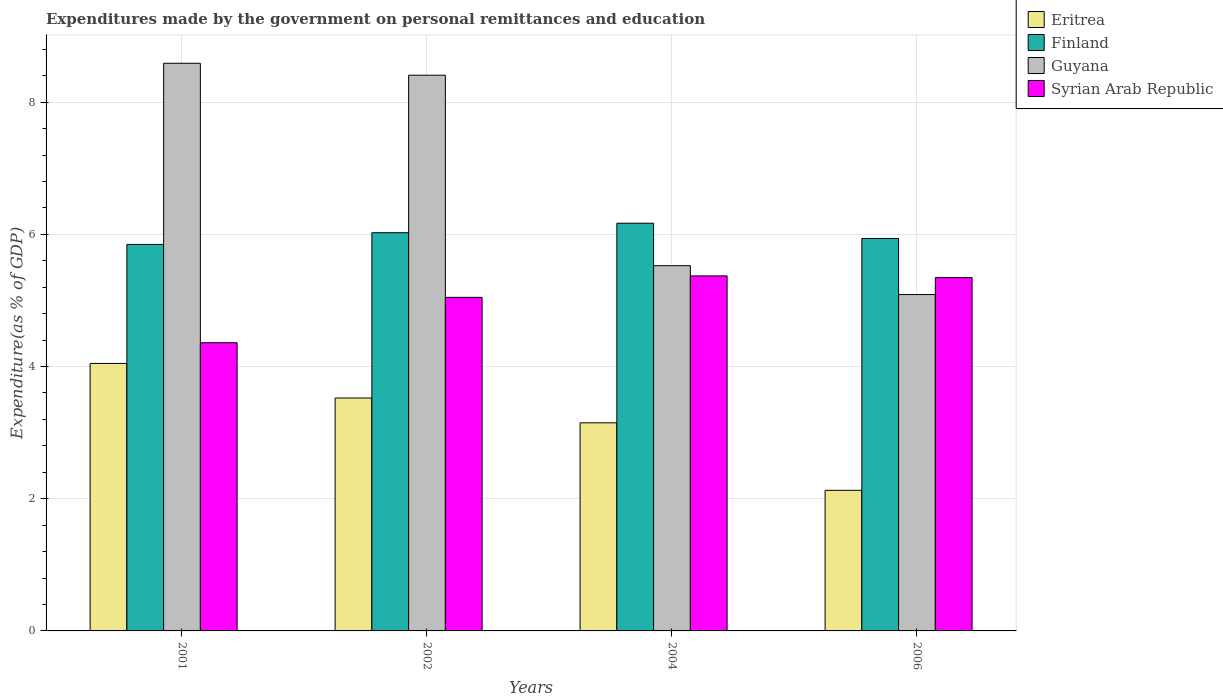How many different coloured bars are there?
Offer a very short reply. 4. Are the number of bars per tick equal to the number of legend labels?
Offer a terse response. Yes. Are the number of bars on each tick of the X-axis equal?
Make the answer very short. Yes. How many bars are there on the 2nd tick from the right?
Ensure brevity in your answer.  4. What is the label of the 2nd group of bars from the left?
Offer a terse response. 2002. What is the expenditures made by the government on personal remittances and education in Syrian Arab Republic in 2002?
Keep it short and to the point. 5.05. Across all years, what is the maximum expenditures made by the government on personal remittances and education in Syrian Arab Republic?
Provide a succinct answer. 5.37. Across all years, what is the minimum expenditures made by the government on personal remittances and education in Guyana?
Offer a terse response. 5.09. In which year was the expenditures made by the government on personal remittances and education in Eritrea minimum?
Provide a succinct answer. 2006. What is the total expenditures made by the government on personal remittances and education in Finland in the graph?
Give a very brief answer. 23.98. What is the difference between the expenditures made by the government on personal remittances and education in Eritrea in 2002 and that in 2004?
Give a very brief answer. 0.37. What is the difference between the expenditures made by the government on personal remittances and education in Finland in 2002 and the expenditures made by the government on personal remittances and education in Eritrea in 2004?
Offer a terse response. 2.88. What is the average expenditures made by the government on personal remittances and education in Syrian Arab Republic per year?
Provide a succinct answer. 5.03. In the year 2006, what is the difference between the expenditures made by the government on personal remittances and education in Finland and expenditures made by the government on personal remittances and education in Syrian Arab Republic?
Make the answer very short. 0.59. In how many years, is the expenditures made by the government on personal remittances and education in Finland greater than 8.4 %?
Keep it short and to the point. 0. What is the ratio of the expenditures made by the government on personal remittances and education in Finland in 2004 to that in 2006?
Your answer should be compact. 1.04. Is the difference between the expenditures made by the government on personal remittances and education in Finland in 2001 and 2006 greater than the difference between the expenditures made by the government on personal remittances and education in Syrian Arab Republic in 2001 and 2006?
Your answer should be compact. Yes. What is the difference between the highest and the second highest expenditures made by the government on personal remittances and education in Eritrea?
Provide a short and direct response. 0.52. What is the difference between the highest and the lowest expenditures made by the government on personal remittances and education in Eritrea?
Ensure brevity in your answer.  1.92. Is the sum of the expenditures made by the government on personal remittances and education in Finland in 2002 and 2004 greater than the maximum expenditures made by the government on personal remittances and education in Syrian Arab Republic across all years?
Give a very brief answer. Yes. What does the 4th bar from the left in 2001 represents?
Offer a terse response. Syrian Arab Republic. What does the 2nd bar from the right in 2001 represents?
Offer a very short reply. Guyana. Is it the case that in every year, the sum of the expenditures made by the government on personal remittances and education in Finland and expenditures made by the government on personal remittances and education in Eritrea is greater than the expenditures made by the government on personal remittances and education in Syrian Arab Republic?
Your response must be concise. Yes. How many bars are there?
Your response must be concise. 16. Are all the bars in the graph horizontal?
Ensure brevity in your answer.  No. How many years are there in the graph?
Your answer should be very brief. 4. What is the difference between two consecutive major ticks on the Y-axis?
Give a very brief answer. 2. Does the graph contain any zero values?
Ensure brevity in your answer.  No. Does the graph contain grids?
Ensure brevity in your answer.  Yes. What is the title of the graph?
Your response must be concise. Expenditures made by the government on personal remittances and education. What is the label or title of the X-axis?
Offer a very short reply. Years. What is the label or title of the Y-axis?
Make the answer very short. Expenditure(as % of GDP). What is the Expenditure(as % of GDP) in Eritrea in 2001?
Your answer should be very brief. 4.05. What is the Expenditure(as % of GDP) in Finland in 2001?
Make the answer very short. 5.85. What is the Expenditure(as % of GDP) in Guyana in 2001?
Ensure brevity in your answer.  8.59. What is the Expenditure(as % of GDP) of Syrian Arab Republic in 2001?
Provide a short and direct response. 4.36. What is the Expenditure(as % of GDP) of Eritrea in 2002?
Give a very brief answer. 3.52. What is the Expenditure(as % of GDP) in Finland in 2002?
Give a very brief answer. 6.02. What is the Expenditure(as % of GDP) in Guyana in 2002?
Give a very brief answer. 8.41. What is the Expenditure(as % of GDP) in Syrian Arab Republic in 2002?
Provide a short and direct response. 5.05. What is the Expenditure(as % of GDP) of Eritrea in 2004?
Keep it short and to the point. 3.15. What is the Expenditure(as % of GDP) in Finland in 2004?
Make the answer very short. 6.17. What is the Expenditure(as % of GDP) in Guyana in 2004?
Provide a succinct answer. 5.53. What is the Expenditure(as % of GDP) in Syrian Arab Republic in 2004?
Provide a succinct answer. 5.37. What is the Expenditure(as % of GDP) of Eritrea in 2006?
Provide a short and direct response. 2.13. What is the Expenditure(as % of GDP) of Finland in 2006?
Provide a succinct answer. 5.94. What is the Expenditure(as % of GDP) of Guyana in 2006?
Give a very brief answer. 5.09. What is the Expenditure(as % of GDP) of Syrian Arab Republic in 2006?
Your response must be concise. 5.35. Across all years, what is the maximum Expenditure(as % of GDP) in Eritrea?
Your answer should be very brief. 4.05. Across all years, what is the maximum Expenditure(as % of GDP) in Finland?
Offer a terse response. 6.17. Across all years, what is the maximum Expenditure(as % of GDP) in Guyana?
Keep it short and to the point. 8.59. Across all years, what is the maximum Expenditure(as % of GDP) in Syrian Arab Republic?
Keep it short and to the point. 5.37. Across all years, what is the minimum Expenditure(as % of GDP) in Eritrea?
Provide a short and direct response. 2.13. Across all years, what is the minimum Expenditure(as % of GDP) of Finland?
Offer a terse response. 5.85. Across all years, what is the minimum Expenditure(as % of GDP) in Guyana?
Keep it short and to the point. 5.09. Across all years, what is the minimum Expenditure(as % of GDP) in Syrian Arab Republic?
Offer a terse response. 4.36. What is the total Expenditure(as % of GDP) in Eritrea in the graph?
Provide a succinct answer. 12.85. What is the total Expenditure(as % of GDP) in Finland in the graph?
Ensure brevity in your answer.  23.98. What is the total Expenditure(as % of GDP) of Guyana in the graph?
Give a very brief answer. 27.61. What is the total Expenditure(as % of GDP) of Syrian Arab Republic in the graph?
Offer a terse response. 20.12. What is the difference between the Expenditure(as % of GDP) in Eritrea in 2001 and that in 2002?
Offer a very short reply. 0.52. What is the difference between the Expenditure(as % of GDP) in Finland in 2001 and that in 2002?
Provide a short and direct response. -0.18. What is the difference between the Expenditure(as % of GDP) in Guyana in 2001 and that in 2002?
Keep it short and to the point. 0.18. What is the difference between the Expenditure(as % of GDP) of Syrian Arab Republic in 2001 and that in 2002?
Keep it short and to the point. -0.69. What is the difference between the Expenditure(as % of GDP) of Eritrea in 2001 and that in 2004?
Offer a very short reply. 0.9. What is the difference between the Expenditure(as % of GDP) of Finland in 2001 and that in 2004?
Provide a succinct answer. -0.32. What is the difference between the Expenditure(as % of GDP) in Guyana in 2001 and that in 2004?
Make the answer very short. 3.06. What is the difference between the Expenditure(as % of GDP) of Syrian Arab Republic in 2001 and that in 2004?
Offer a terse response. -1.01. What is the difference between the Expenditure(as % of GDP) of Eritrea in 2001 and that in 2006?
Provide a succinct answer. 1.92. What is the difference between the Expenditure(as % of GDP) of Finland in 2001 and that in 2006?
Your answer should be very brief. -0.09. What is the difference between the Expenditure(as % of GDP) of Guyana in 2001 and that in 2006?
Give a very brief answer. 3.5. What is the difference between the Expenditure(as % of GDP) in Syrian Arab Republic in 2001 and that in 2006?
Give a very brief answer. -0.99. What is the difference between the Expenditure(as % of GDP) in Eritrea in 2002 and that in 2004?
Ensure brevity in your answer.  0.37. What is the difference between the Expenditure(as % of GDP) of Finland in 2002 and that in 2004?
Make the answer very short. -0.14. What is the difference between the Expenditure(as % of GDP) of Guyana in 2002 and that in 2004?
Your response must be concise. 2.88. What is the difference between the Expenditure(as % of GDP) in Syrian Arab Republic in 2002 and that in 2004?
Give a very brief answer. -0.32. What is the difference between the Expenditure(as % of GDP) in Eritrea in 2002 and that in 2006?
Your answer should be compact. 1.4. What is the difference between the Expenditure(as % of GDP) in Finland in 2002 and that in 2006?
Make the answer very short. 0.09. What is the difference between the Expenditure(as % of GDP) of Guyana in 2002 and that in 2006?
Give a very brief answer. 3.32. What is the difference between the Expenditure(as % of GDP) in Syrian Arab Republic in 2002 and that in 2006?
Provide a succinct answer. -0.3. What is the difference between the Expenditure(as % of GDP) of Eritrea in 2004 and that in 2006?
Keep it short and to the point. 1.02. What is the difference between the Expenditure(as % of GDP) in Finland in 2004 and that in 2006?
Provide a short and direct response. 0.23. What is the difference between the Expenditure(as % of GDP) of Guyana in 2004 and that in 2006?
Give a very brief answer. 0.44. What is the difference between the Expenditure(as % of GDP) in Syrian Arab Republic in 2004 and that in 2006?
Provide a succinct answer. 0.03. What is the difference between the Expenditure(as % of GDP) in Eritrea in 2001 and the Expenditure(as % of GDP) in Finland in 2002?
Your answer should be compact. -1.98. What is the difference between the Expenditure(as % of GDP) in Eritrea in 2001 and the Expenditure(as % of GDP) in Guyana in 2002?
Offer a terse response. -4.36. What is the difference between the Expenditure(as % of GDP) of Eritrea in 2001 and the Expenditure(as % of GDP) of Syrian Arab Republic in 2002?
Provide a short and direct response. -1. What is the difference between the Expenditure(as % of GDP) of Finland in 2001 and the Expenditure(as % of GDP) of Guyana in 2002?
Your response must be concise. -2.56. What is the difference between the Expenditure(as % of GDP) in Finland in 2001 and the Expenditure(as % of GDP) in Syrian Arab Republic in 2002?
Your response must be concise. 0.8. What is the difference between the Expenditure(as % of GDP) of Guyana in 2001 and the Expenditure(as % of GDP) of Syrian Arab Republic in 2002?
Ensure brevity in your answer.  3.54. What is the difference between the Expenditure(as % of GDP) in Eritrea in 2001 and the Expenditure(as % of GDP) in Finland in 2004?
Offer a terse response. -2.12. What is the difference between the Expenditure(as % of GDP) in Eritrea in 2001 and the Expenditure(as % of GDP) in Guyana in 2004?
Your response must be concise. -1.48. What is the difference between the Expenditure(as % of GDP) in Eritrea in 2001 and the Expenditure(as % of GDP) in Syrian Arab Republic in 2004?
Offer a terse response. -1.32. What is the difference between the Expenditure(as % of GDP) in Finland in 2001 and the Expenditure(as % of GDP) in Guyana in 2004?
Give a very brief answer. 0.32. What is the difference between the Expenditure(as % of GDP) of Finland in 2001 and the Expenditure(as % of GDP) of Syrian Arab Republic in 2004?
Provide a succinct answer. 0.48. What is the difference between the Expenditure(as % of GDP) of Guyana in 2001 and the Expenditure(as % of GDP) of Syrian Arab Republic in 2004?
Your response must be concise. 3.22. What is the difference between the Expenditure(as % of GDP) of Eritrea in 2001 and the Expenditure(as % of GDP) of Finland in 2006?
Your answer should be compact. -1.89. What is the difference between the Expenditure(as % of GDP) in Eritrea in 2001 and the Expenditure(as % of GDP) in Guyana in 2006?
Make the answer very short. -1.04. What is the difference between the Expenditure(as % of GDP) in Eritrea in 2001 and the Expenditure(as % of GDP) in Syrian Arab Republic in 2006?
Offer a terse response. -1.3. What is the difference between the Expenditure(as % of GDP) in Finland in 2001 and the Expenditure(as % of GDP) in Guyana in 2006?
Your response must be concise. 0.76. What is the difference between the Expenditure(as % of GDP) of Finland in 2001 and the Expenditure(as % of GDP) of Syrian Arab Republic in 2006?
Your answer should be very brief. 0.5. What is the difference between the Expenditure(as % of GDP) of Guyana in 2001 and the Expenditure(as % of GDP) of Syrian Arab Republic in 2006?
Your answer should be very brief. 3.24. What is the difference between the Expenditure(as % of GDP) of Eritrea in 2002 and the Expenditure(as % of GDP) of Finland in 2004?
Offer a very short reply. -2.64. What is the difference between the Expenditure(as % of GDP) in Eritrea in 2002 and the Expenditure(as % of GDP) in Guyana in 2004?
Your response must be concise. -2. What is the difference between the Expenditure(as % of GDP) in Eritrea in 2002 and the Expenditure(as % of GDP) in Syrian Arab Republic in 2004?
Your answer should be compact. -1.85. What is the difference between the Expenditure(as % of GDP) of Finland in 2002 and the Expenditure(as % of GDP) of Guyana in 2004?
Make the answer very short. 0.5. What is the difference between the Expenditure(as % of GDP) of Finland in 2002 and the Expenditure(as % of GDP) of Syrian Arab Republic in 2004?
Provide a short and direct response. 0.65. What is the difference between the Expenditure(as % of GDP) in Guyana in 2002 and the Expenditure(as % of GDP) in Syrian Arab Republic in 2004?
Give a very brief answer. 3.04. What is the difference between the Expenditure(as % of GDP) of Eritrea in 2002 and the Expenditure(as % of GDP) of Finland in 2006?
Your response must be concise. -2.41. What is the difference between the Expenditure(as % of GDP) of Eritrea in 2002 and the Expenditure(as % of GDP) of Guyana in 2006?
Your answer should be compact. -1.57. What is the difference between the Expenditure(as % of GDP) in Eritrea in 2002 and the Expenditure(as % of GDP) in Syrian Arab Republic in 2006?
Give a very brief answer. -1.82. What is the difference between the Expenditure(as % of GDP) in Finland in 2002 and the Expenditure(as % of GDP) in Guyana in 2006?
Provide a succinct answer. 0.94. What is the difference between the Expenditure(as % of GDP) in Finland in 2002 and the Expenditure(as % of GDP) in Syrian Arab Republic in 2006?
Your answer should be very brief. 0.68. What is the difference between the Expenditure(as % of GDP) in Guyana in 2002 and the Expenditure(as % of GDP) in Syrian Arab Republic in 2006?
Your response must be concise. 3.06. What is the difference between the Expenditure(as % of GDP) in Eritrea in 2004 and the Expenditure(as % of GDP) in Finland in 2006?
Make the answer very short. -2.79. What is the difference between the Expenditure(as % of GDP) in Eritrea in 2004 and the Expenditure(as % of GDP) in Guyana in 2006?
Offer a terse response. -1.94. What is the difference between the Expenditure(as % of GDP) of Eritrea in 2004 and the Expenditure(as % of GDP) of Syrian Arab Republic in 2006?
Provide a short and direct response. -2.2. What is the difference between the Expenditure(as % of GDP) of Finland in 2004 and the Expenditure(as % of GDP) of Guyana in 2006?
Keep it short and to the point. 1.08. What is the difference between the Expenditure(as % of GDP) in Finland in 2004 and the Expenditure(as % of GDP) in Syrian Arab Republic in 2006?
Your response must be concise. 0.82. What is the difference between the Expenditure(as % of GDP) of Guyana in 2004 and the Expenditure(as % of GDP) of Syrian Arab Republic in 2006?
Provide a short and direct response. 0.18. What is the average Expenditure(as % of GDP) of Eritrea per year?
Your answer should be very brief. 3.21. What is the average Expenditure(as % of GDP) in Finland per year?
Make the answer very short. 5.99. What is the average Expenditure(as % of GDP) in Guyana per year?
Keep it short and to the point. 6.9. What is the average Expenditure(as % of GDP) in Syrian Arab Republic per year?
Ensure brevity in your answer.  5.03. In the year 2001, what is the difference between the Expenditure(as % of GDP) in Eritrea and Expenditure(as % of GDP) in Finland?
Provide a short and direct response. -1.8. In the year 2001, what is the difference between the Expenditure(as % of GDP) of Eritrea and Expenditure(as % of GDP) of Guyana?
Give a very brief answer. -4.54. In the year 2001, what is the difference between the Expenditure(as % of GDP) of Eritrea and Expenditure(as % of GDP) of Syrian Arab Republic?
Give a very brief answer. -0.31. In the year 2001, what is the difference between the Expenditure(as % of GDP) of Finland and Expenditure(as % of GDP) of Guyana?
Ensure brevity in your answer.  -2.74. In the year 2001, what is the difference between the Expenditure(as % of GDP) of Finland and Expenditure(as % of GDP) of Syrian Arab Republic?
Your answer should be very brief. 1.49. In the year 2001, what is the difference between the Expenditure(as % of GDP) in Guyana and Expenditure(as % of GDP) in Syrian Arab Republic?
Offer a terse response. 4.23. In the year 2002, what is the difference between the Expenditure(as % of GDP) of Eritrea and Expenditure(as % of GDP) of Finland?
Your response must be concise. -2.5. In the year 2002, what is the difference between the Expenditure(as % of GDP) of Eritrea and Expenditure(as % of GDP) of Guyana?
Offer a terse response. -4.88. In the year 2002, what is the difference between the Expenditure(as % of GDP) in Eritrea and Expenditure(as % of GDP) in Syrian Arab Republic?
Make the answer very short. -1.52. In the year 2002, what is the difference between the Expenditure(as % of GDP) in Finland and Expenditure(as % of GDP) in Guyana?
Make the answer very short. -2.38. In the year 2002, what is the difference between the Expenditure(as % of GDP) in Finland and Expenditure(as % of GDP) in Syrian Arab Republic?
Your answer should be very brief. 0.98. In the year 2002, what is the difference between the Expenditure(as % of GDP) of Guyana and Expenditure(as % of GDP) of Syrian Arab Republic?
Make the answer very short. 3.36. In the year 2004, what is the difference between the Expenditure(as % of GDP) of Eritrea and Expenditure(as % of GDP) of Finland?
Your answer should be very brief. -3.02. In the year 2004, what is the difference between the Expenditure(as % of GDP) of Eritrea and Expenditure(as % of GDP) of Guyana?
Your response must be concise. -2.38. In the year 2004, what is the difference between the Expenditure(as % of GDP) of Eritrea and Expenditure(as % of GDP) of Syrian Arab Republic?
Your response must be concise. -2.22. In the year 2004, what is the difference between the Expenditure(as % of GDP) of Finland and Expenditure(as % of GDP) of Guyana?
Your answer should be compact. 0.64. In the year 2004, what is the difference between the Expenditure(as % of GDP) of Finland and Expenditure(as % of GDP) of Syrian Arab Republic?
Ensure brevity in your answer.  0.8. In the year 2004, what is the difference between the Expenditure(as % of GDP) in Guyana and Expenditure(as % of GDP) in Syrian Arab Republic?
Ensure brevity in your answer.  0.15. In the year 2006, what is the difference between the Expenditure(as % of GDP) in Eritrea and Expenditure(as % of GDP) in Finland?
Ensure brevity in your answer.  -3.81. In the year 2006, what is the difference between the Expenditure(as % of GDP) of Eritrea and Expenditure(as % of GDP) of Guyana?
Your answer should be very brief. -2.96. In the year 2006, what is the difference between the Expenditure(as % of GDP) in Eritrea and Expenditure(as % of GDP) in Syrian Arab Republic?
Your answer should be compact. -3.22. In the year 2006, what is the difference between the Expenditure(as % of GDP) in Finland and Expenditure(as % of GDP) in Guyana?
Make the answer very short. 0.85. In the year 2006, what is the difference between the Expenditure(as % of GDP) in Finland and Expenditure(as % of GDP) in Syrian Arab Republic?
Keep it short and to the point. 0.59. In the year 2006, what is the difference between the Expenditure(as % of GDP) of Guyana and Expenditure(as % of GDP) of Syrian Arab Republic?
Offer a very short reply. -0.26. What is the ratio of the Expenditure(as % of GDP) of Eritrea in 2001 to that in 2002?
Your answer should be compact. 1.15. What is the ratio of the Expenditure(as % of GDP) of Finland in 2001 to that in 2002?
Give a very brief answer. 0.97. What is the ratio of the Expenditure(as % of GDP) of Guyana in 2001 to that in 2002?
Keep it short and to the point. 1.02. What is the ratio of the Expenditure(as % of GDP) in Syrian Arab Republic in 2001 to that in 2002?
Ensure brevity in your answer.  0.86. What is the ratio of the Expenditure(as % of GDP) of Eritrea in 2001 to that in 2004?
Ensure brevity in your answer.  1.29. What is the ratio of the Expenditure(as % of GDP) in Finland in 2001 to that in 2004?
Your answer should be compact. 0.95. What is the ratio of the Expenditure(as % of GDP) in Guyana in 2001 to that in 2004?
Your answer should be compact. 1.55. What is the ratio of the Expenditure(as % of GDP) of Syrian Arab Republic in 2001 to that in 2004?
Your response must be concise. 0.81. What is the ratio of the Expenditure(as % of GDP) of Eritrea in 2001 to that in 2006?
Your answer should be compact. 1.9. What is the ratio of the Expenditure(as % of GDP) in Finland in 2001 to that in 2006?
Offer a very short reply. 0.98. What is the ratio of the Expenditure(as % of GDP) of Guyana in 2001 to that in 2006?
Offer a very short reply. 1.69. What is the ratio of the Expenditure(as % of GDP) in Syrian Arab Republic in 2001 to that in 2006?
Make the answer very short. 0.82. What is the ratio of the Expenditure(as % of GDP) of Eritrea in 2002 to that in 2004?
Your answer should be compact. 1.12. What is the ratio of the Expenditure(as % of GDP) of Finland in 2002 to that in 2004?
Provide a succinct answer. 0.98. What is the ratio of the Expenditure(as % of GDP) of Guyana in 2002 to that in 2004?
Offer a very short reply. 1.52. What is the ratio of the Expenditure(as % of GDP) in Syrian Arab Republic in 2002 to that in 2004?
Give a very brief answer. 0.94. What is the ratio of the Expenditure(as % of GDP) in Eritrea in 2002 to that in 2006?
Your answer should be compact. 1.66. What is the ratio of the Expenditure(as % of GDP) of Finland in 2002 to that in 2006?
Your response must be concise. 1.01. What is the ratio of the Expenditure(as % of GDP) in Guyana in 2002 to that in 2006?
Ensure brevity in your answer.  1.65. What is the ratio of the Expenditure(as % of GDP) in Syrian Arab Republic in 2002 to that in 2006?
Give a very brief answer. 0.94. What is the ratio of the Expenditure(as % of GDP) of Eritrea in 2004 to that in 2006?
Provide a succinct answer. 1.48. What is the ratio of the Expenditure(as % of GDP) in Finland in 2004 to that in 2006?
Keep it short and to the point. 1.04. What is the ratio of the Expenditure(as % of GDP) of Guyana in 2004 to that in 2006?
Your answer should be very brief. 1.09. What is the difference between the highest and the second highest Expenditure(as % of GDP) of Eritrea?
Give a very brief answer. 0.52. What is the difference between the highest and the second highest Expenditure(as % of GDP) of Finland?
Give a very brief answer. 0.14. What is the difference between the highest and the second highest Expenditure(as % of GDP) of Guyana?
Make the answer very short. 0.18. What is the difference between the highest and the second highest Expenditure(as % of GDP) of Syrian Arab Republic?
Offer a very short reply. 0.03. What is the difference between the highest and the lowest Expenditure(as % of GDP) in Eritrea?
Keep it short and to the point. 1.92. What is the difference between the highest and the lowest Expenditure(as % of GDP) in Finland?
Give a very brief answer. 0.32. What is the difference between the highest and the lowest Expenditure(as % of GDP) in Guyana?
Offer a very short reply. 3.5. 